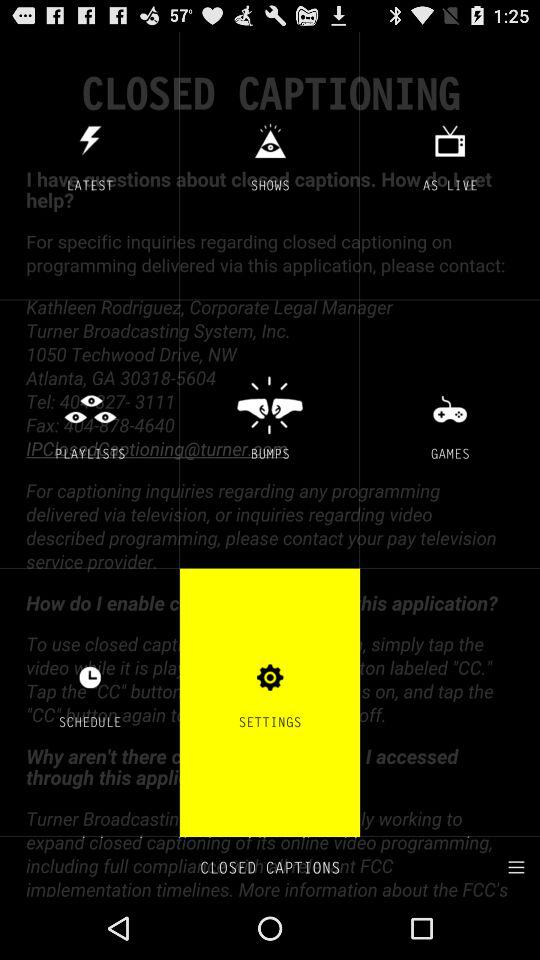Which option is selected? The selected option is "SETTINGS". 